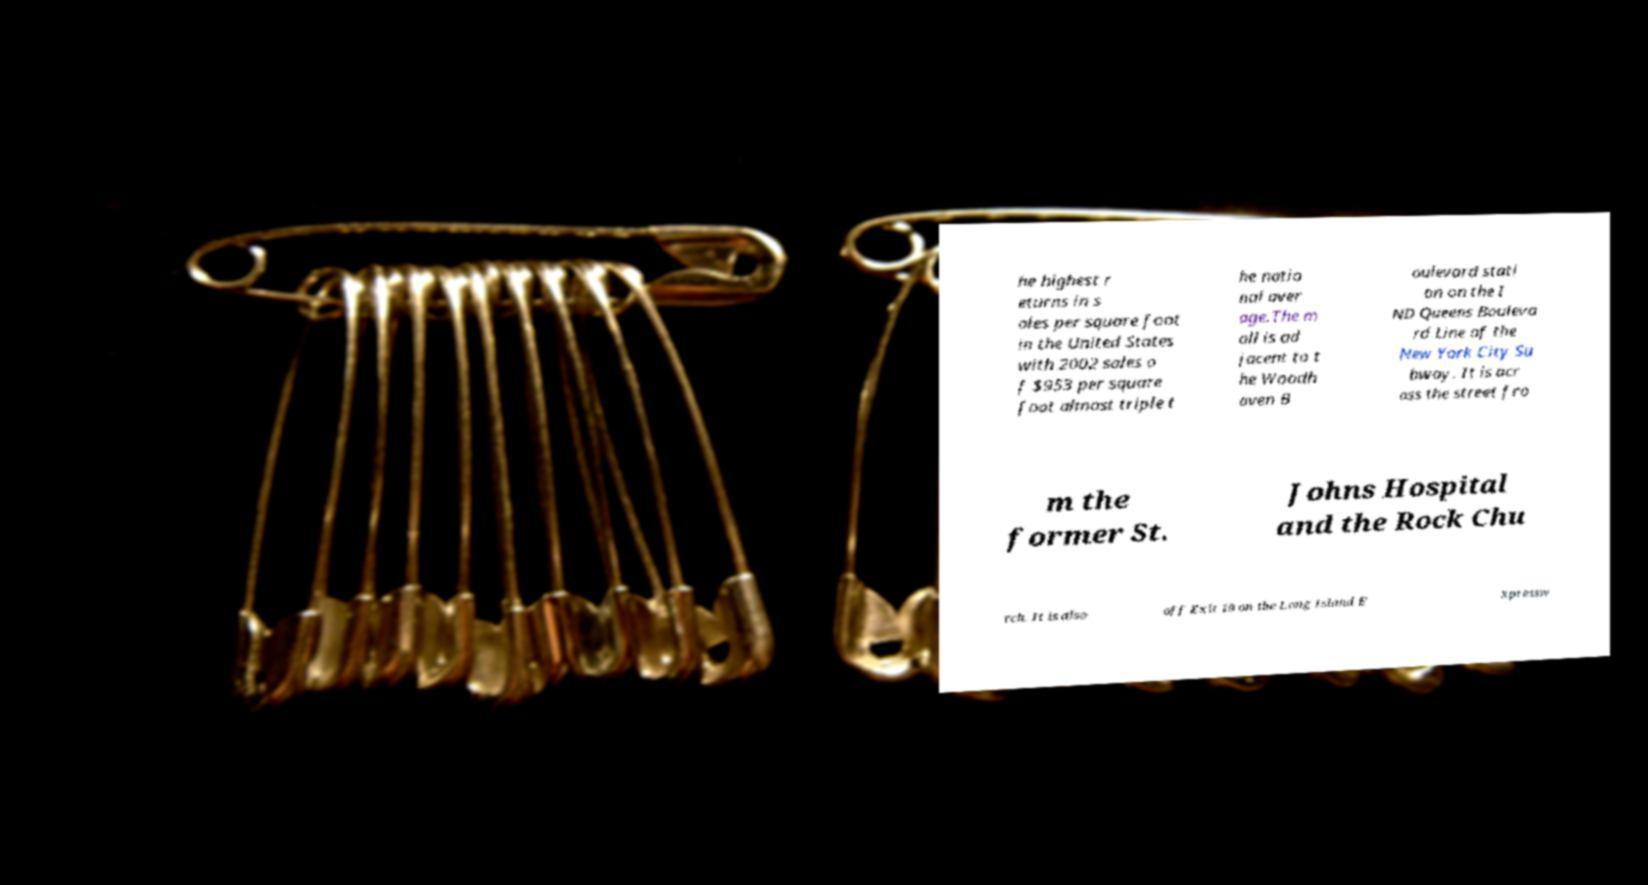What messages or text are displayed in this image? I need them in a readable, typed format. he highest r eturns in s ales per square foot in the United States with 2002 sales o f $953 per square foot almost triple t he natio nal aver age.The m all is ad jacent to t he Woodh aven B oulevard stati on on the I ND Queens Bouleva rd Line of the New York City Su bway. It is acr oss the street fro m the former St. Johns Hospital and the Rock Chu rch. It is also off Exit 19 on the Long Island E xpressw 